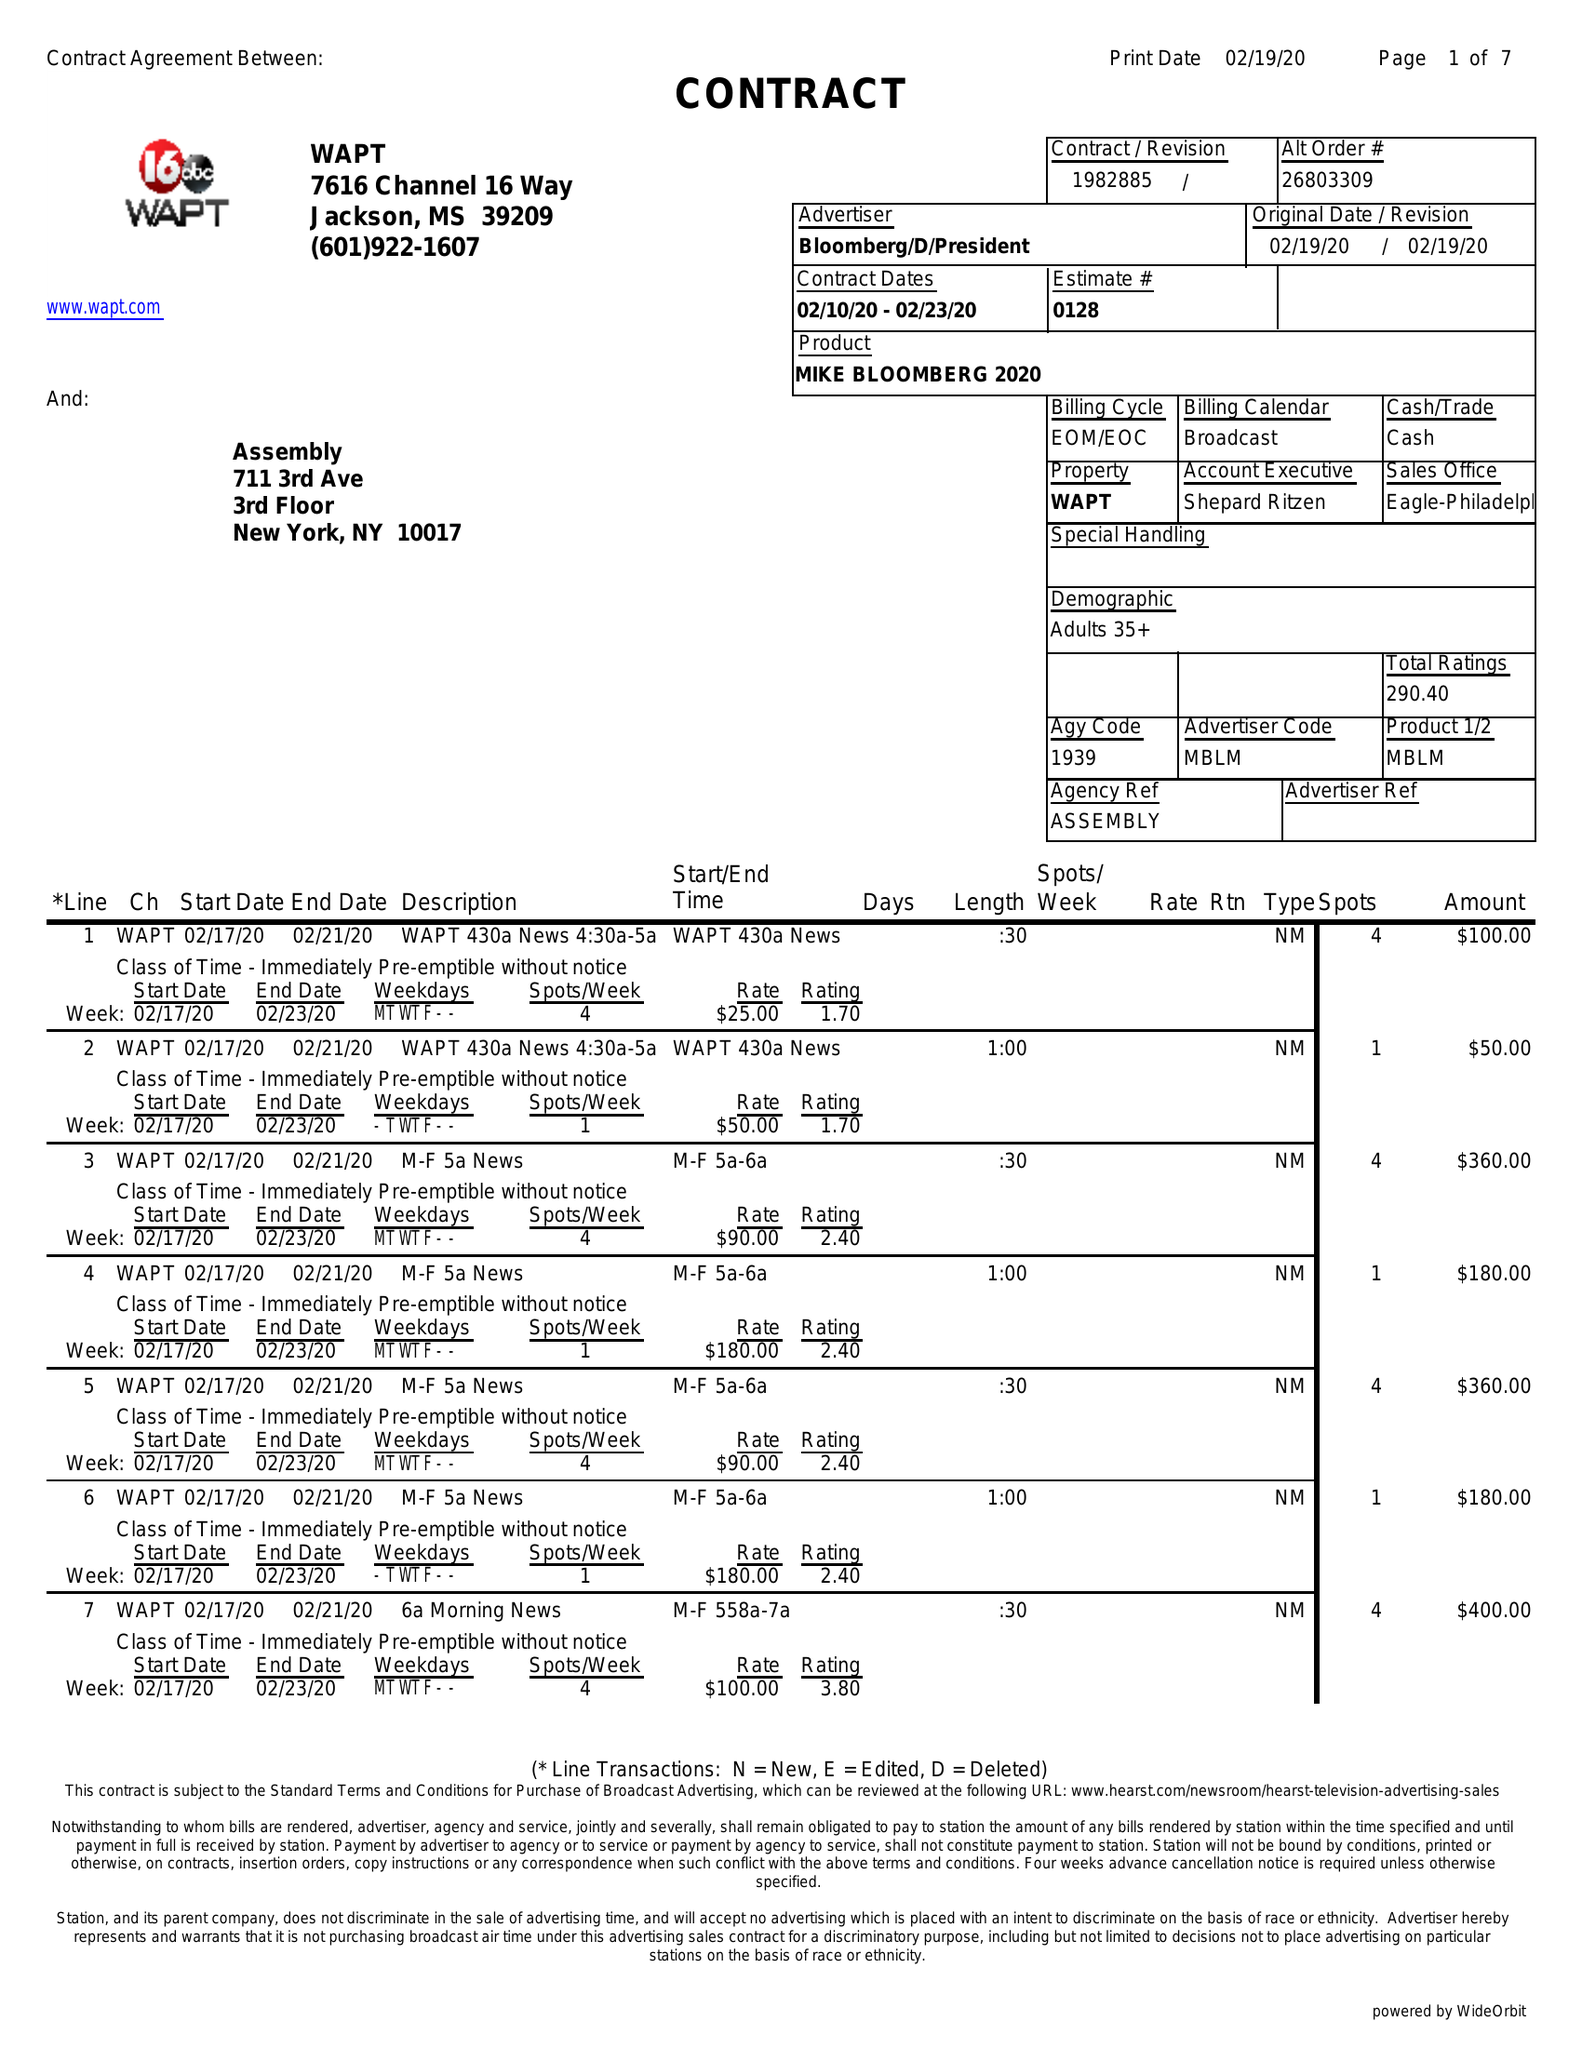What is the value for the advertiser?
Answer the question using a single word or phrase. BLOOMBERG/D/PRESIDENT 